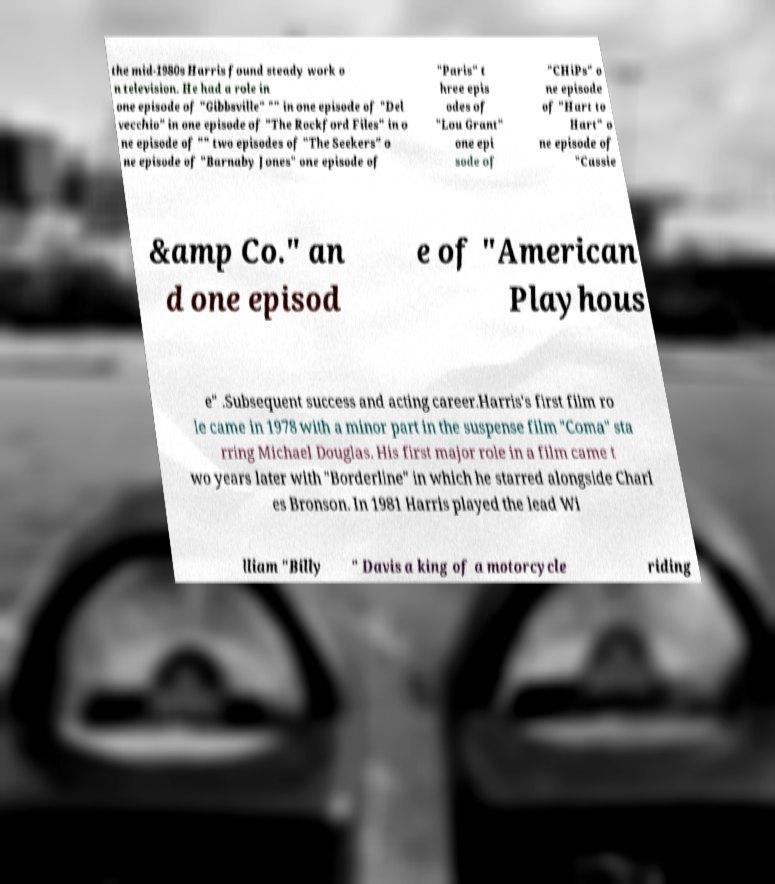Could you extract and type out the text from this image? the mid-1980s Harris found steady work o n television. He had a role in one episode of "Gibbsville" "" in one episode of "Del vecchio" in one episode of "The Rockford Files" in o ne episode of "" two episodes of "The Seekers" o ne episode of "Barnaby Jones" one episode of "Paris" t hree epis odes of "Lou Grant" one epi sode of "CHiPs" o ne episode of "Hart to Hart" o ne episode of "Cassie &amp Co." an d one episod e of "American Playhous e" .Subsequent success and acting career.Harris's first film ro le came in 1978 with a minor part in the suspense film "Coma" sta rring Michael Douglas. His first major role in a film came t wo years later with "Borderline" in which he starred alongside Charl es Bronson. In 1981 Harris played the lead Wi lliam "Billy " Davis a king of a motorcycle riding 